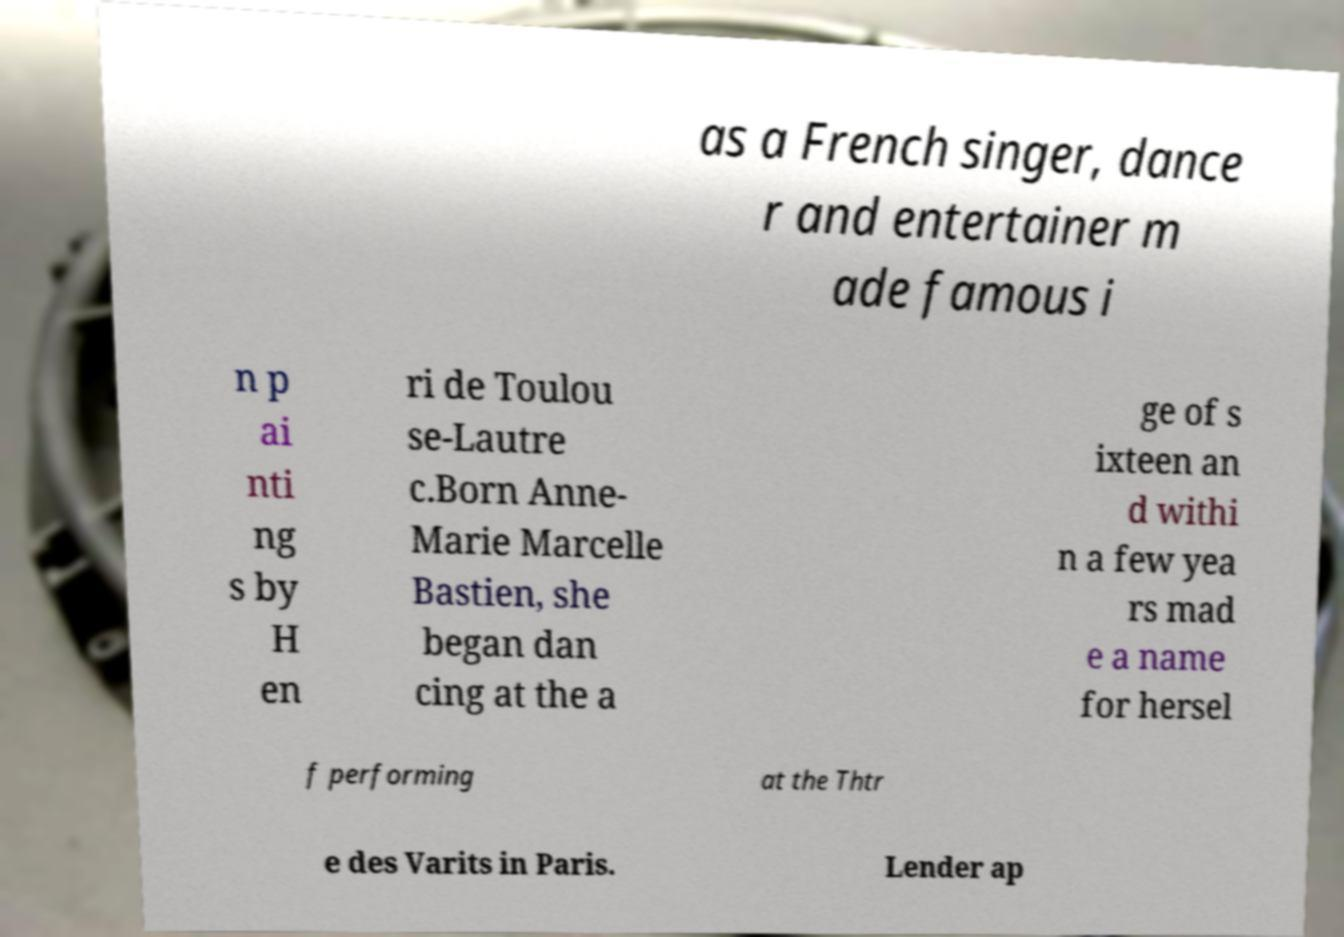What messages or text are displayed in this image? I need them in a readable, typed format. as a French singer, dance r and entertainer m ade famous i n p ai nti ng s by H en ri de Toulou se-Lautre c.Born Anne- Marie Marcelle Bastien, she began dan cing at the a ge of s ixteen an d withi n a few yea rs mad e a name for hersel f performing at the Thtr e des Varits in Paris. Lender ap 